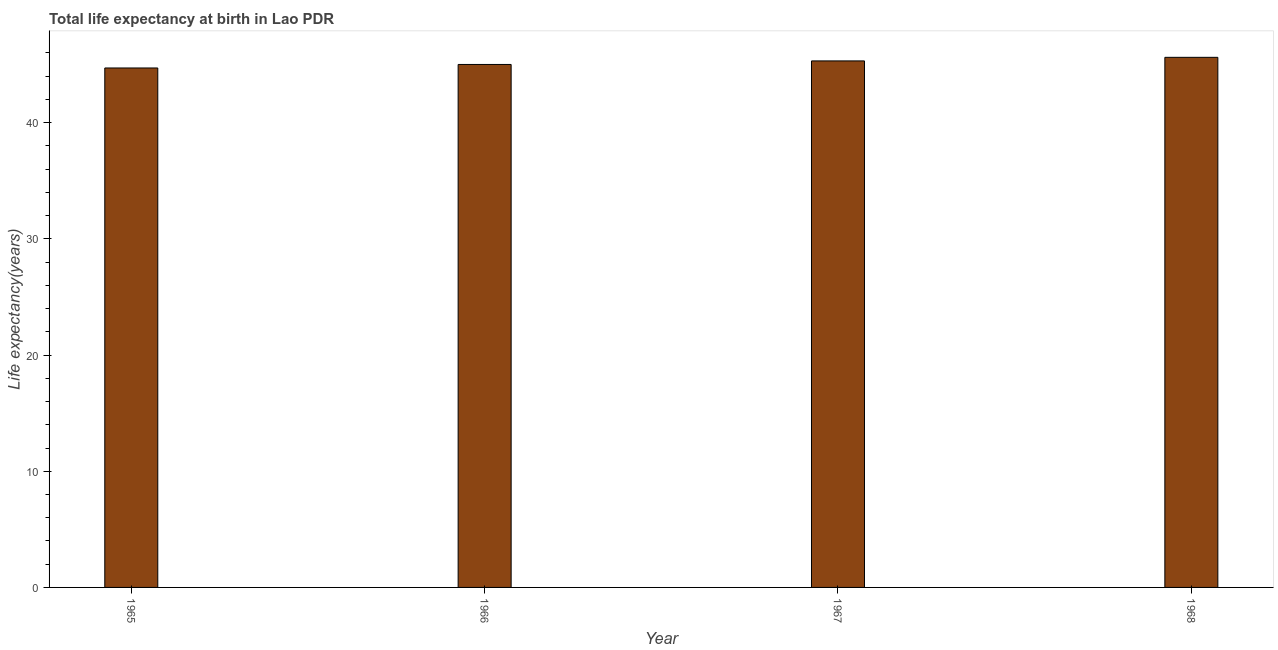Does the graph contain grids?
Your answer should be compact. No. What is the title of the graph?
Your answer should be compact. Total life expectancy at birth in Lao PDR. What is the label or title of the Y-axis?
Provide a succinct answer. Life expectancy(years). What is the life expectancy at birth in 1965?
Provide a succinct answer. 44.71. Across all years, what is the maximum life expectancy at birth?
Ensure brevity in your answer.  45.63. Across all years, what is the minimum life expectancy at birth?
Offer a very short reply. 44.71. In which year was the life expectancy at birth maximum?
Provide a succinct answer. 1968. In which year was the life expectancy at birth minimum?
Your answer should be compact. 1965. What is the sum of the life expectancy at birth?
Ensure brevity in your answer.  180.66. What is the difference between the life expectancy at birth in 1967 and 1968?
Keep it short and to the point. -0.31. What is the average life expectancy at birth per year?
Your response must be concise. 45.17. What is the median life expectancy at birth?
Make the answer very short. 45.16. In how many years, is the life expectancy at birth greater than 18 years?
Offer a very short reply. 4. What is the difference between the highest and the second highest life expectancy at birth?
Offer a terse response. 0.31. Is the sum of the life expectancy at birth in 1966 and 1967 greater than the maximum life expectancy at birth across all years?
Make the answer very short. Yes. In how many years, is the life expectancy at birth greater than the average life expectancy at birth taken over all years?
Provide a succinct answer. 2. Are all the bars in the graph horizontal?
Give a very brief answer. No. How many years are there in the graph?
Your answer should be very brief. 4. Are the values on the major ticks of Y-axis written in scientific E-notation?
Offer a very short reply. No. What is the Life expectancy(years) in 1965?
Your answer should be compact. 44.71. What is the Life expectancy(years) of 1966?
Your answer should be very brief. 45.01. What is the Life expectancy(years) in 1967?
Ensure brevity in your answer.  45.32. What is the Life expectancy(years) in 1968?
Your answer should be compact. 45.63. What is the difference between the Life expectancy(years) in 1965 and 1966?
Make the answer very short. -0.3. What is the difference between the Life expectancy(years) in 1965 and 1967?
Offer a terse response. -0.61. What is the difference between the Life expectancy(years) in 1965 and 1968?
Your answer should be very brief. -0.92. What is the difference between the Life expectancy(years) in 1966 and 1967?
Give a very brief answer. -0.31. What is the difference between the Life expectancy(years) in 1966 and 1968?
Provide a succinct answer. -0.61. What is the difference between the Life expectancy(years) in 1967 and 1968?
Keep it short and to the point. -0.31. What is the ratio of the Life expectancy(years) in 1966 to that in 1968?
Your answer should be very brief. 0.99. What is the ratio of the Life expectancy(years) in 1967 to that in 1968?
Provide a short and direct response. 0.99. 